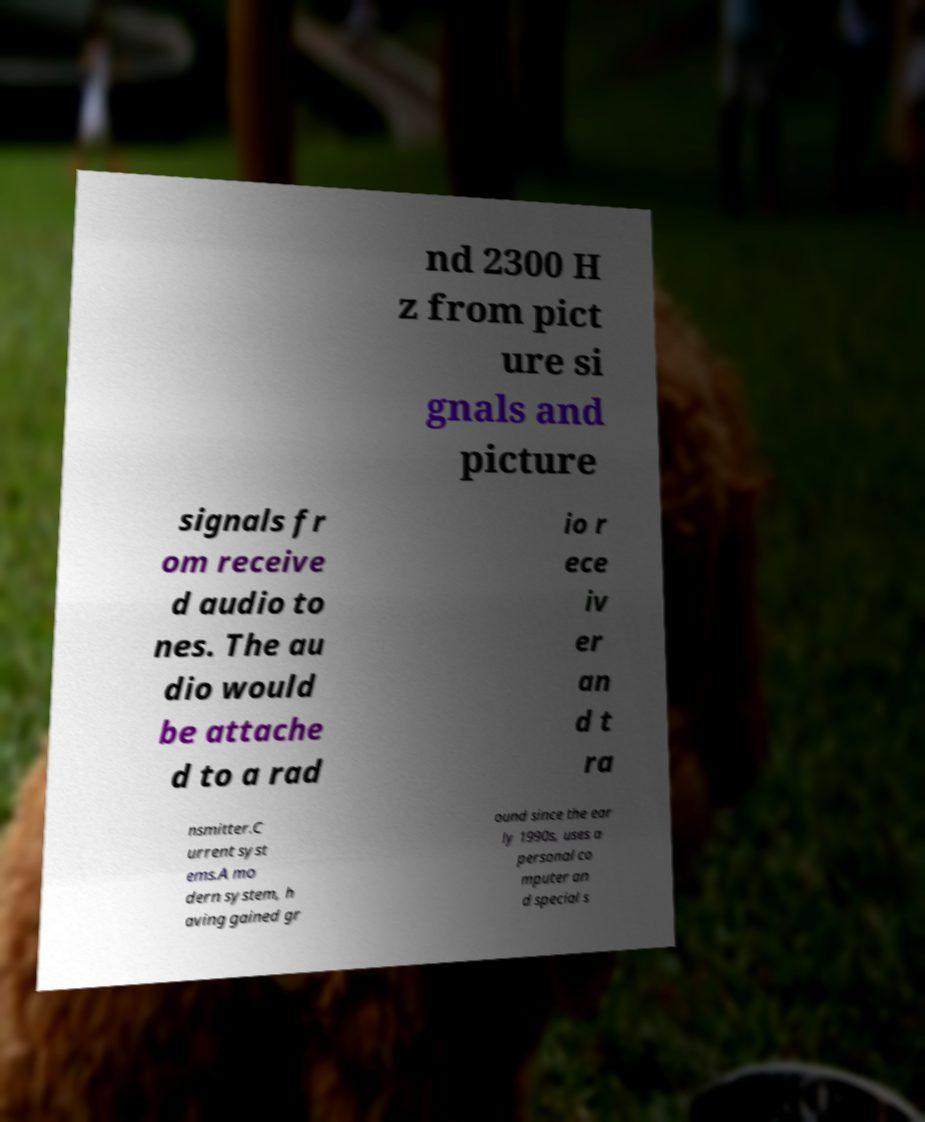I need the written content from this picture converted into text. Can you do that? nd 2300 H z from pict ure si gnals and picture signals fr om receive d audio to nes. The au dio would be attache d to a rad io r ece iv er an d t ra nsmitter.C urrent syst ems.A mo dern system, h aving gained gr ound since the ear ly 1990s, uses a personal co mputer an d special s 